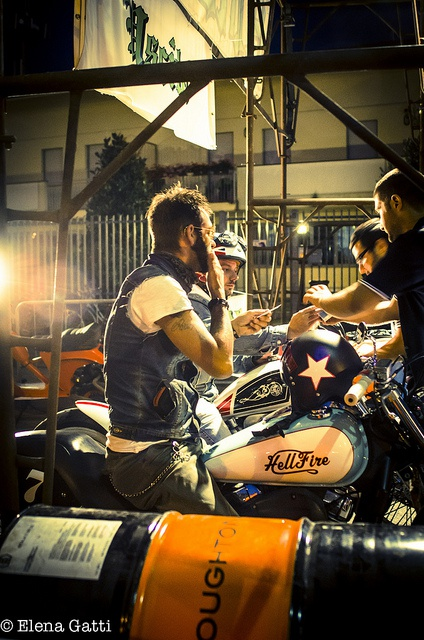Describe the objects in this image and their specific colors. I can see motorcycle in black, orange, gray, and khaki tones, people in black, khaki, gray, and maroon tones, people in black, maroon, and olive tones, motorcycle in black, khaki, ivory, and gray tones, and motorcycle in black, maroon, and brown tones in this image. 